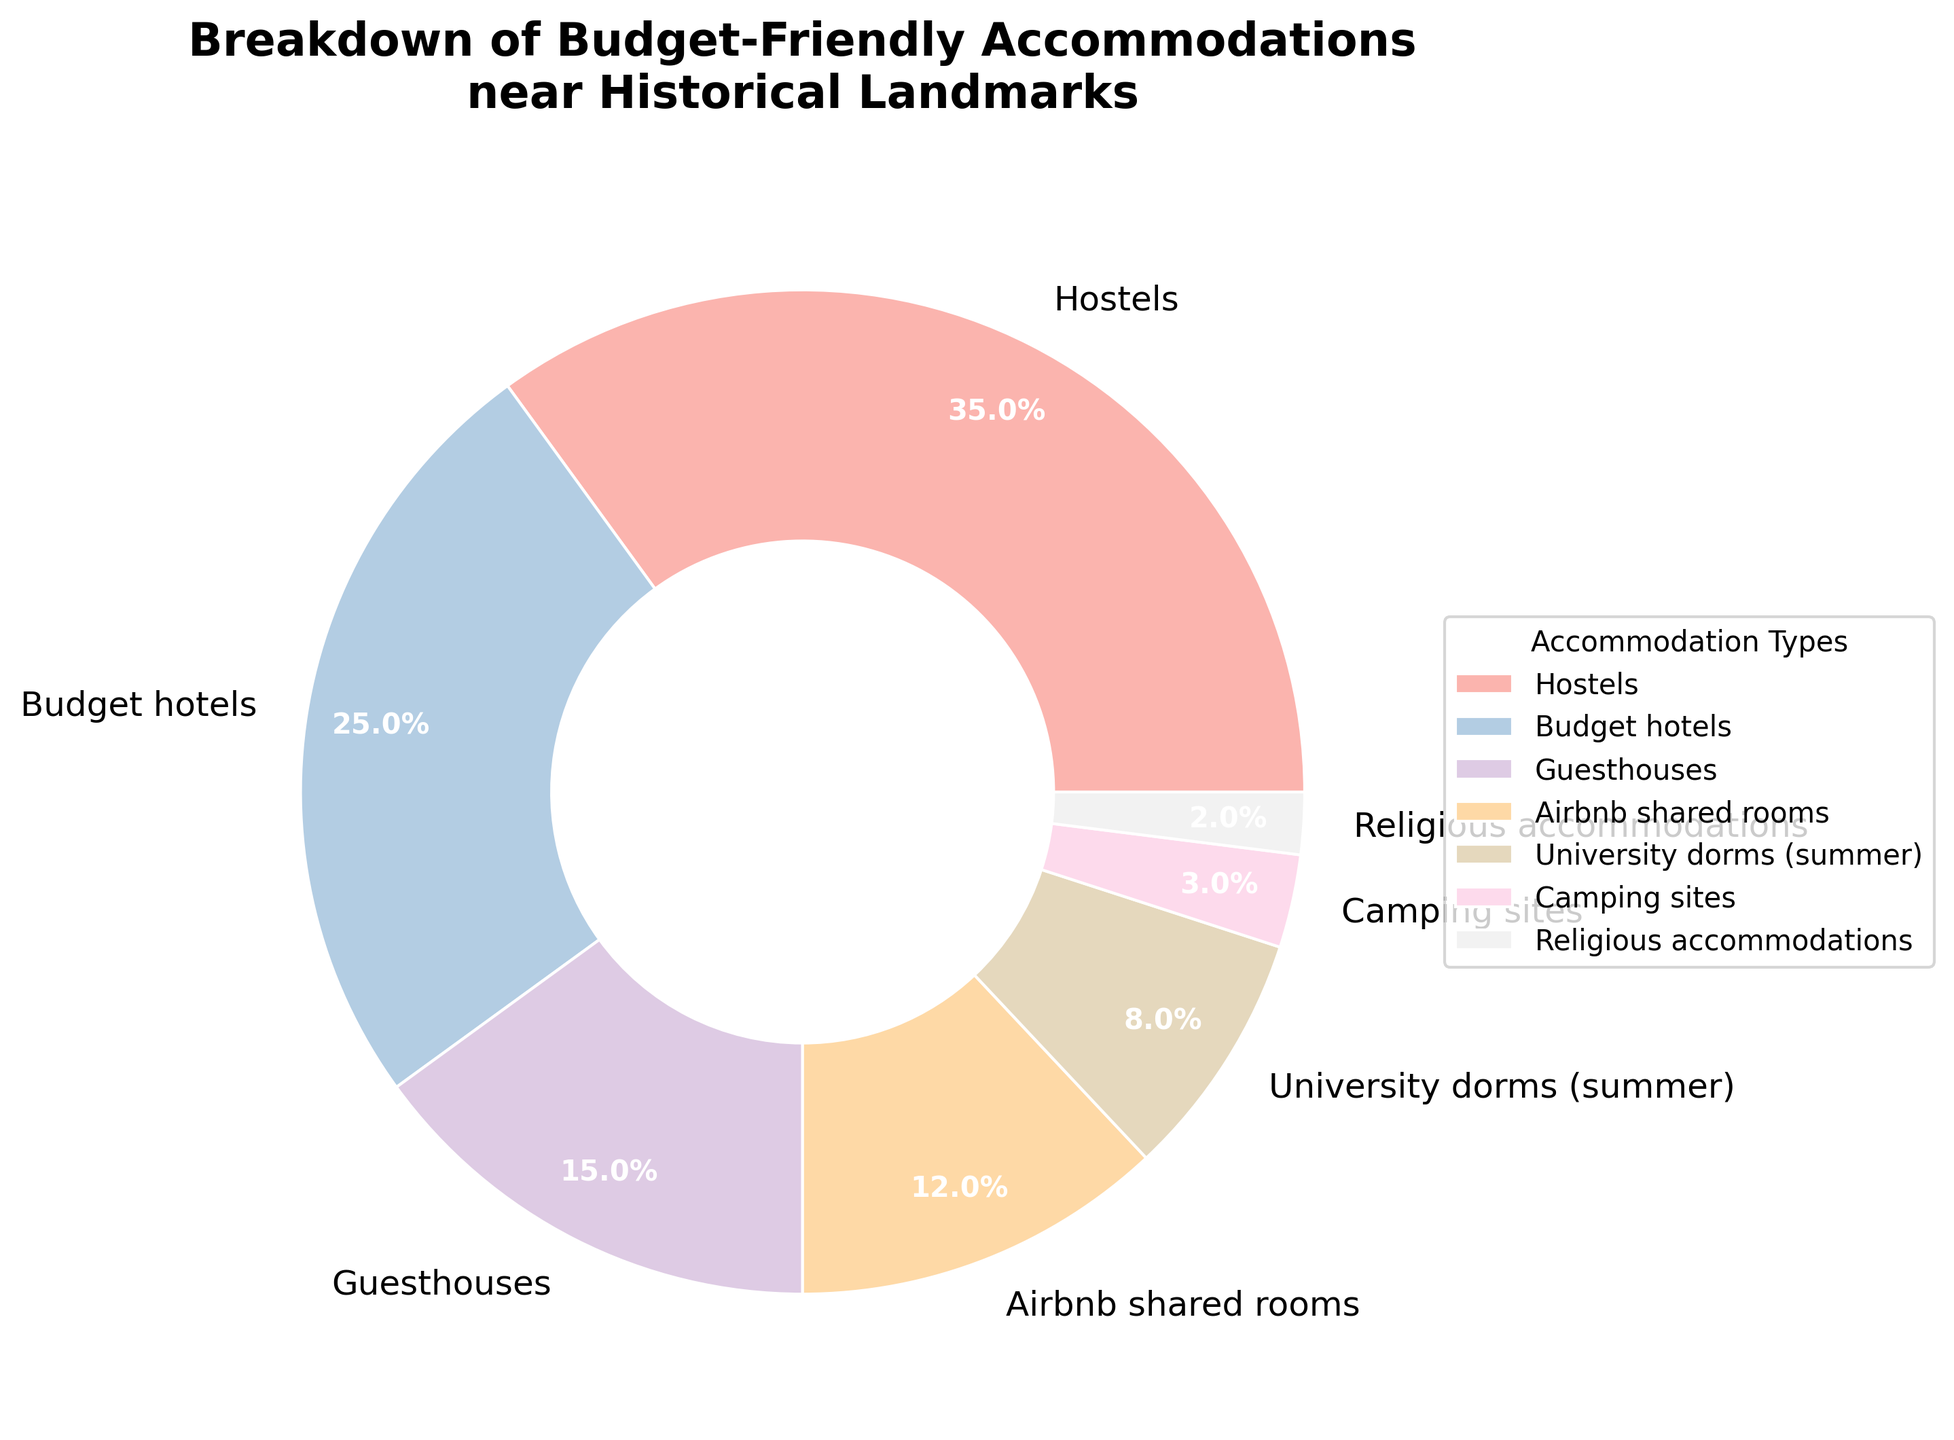What percentage of accommodations are either Hostels or Budget hotels? To find this, sum the percentages of Hostels and Budget hotels. Hostels account for 35% and Budget hotels account for 25%. Thus, 35% + 25% = 60%.
Answer: 60% Which accommodation type has the smallest percentage? Look at the percentages for all accommodation types. The smallest percentage is 2%, which corresponds to Religious accommodations.
Answer: Religious accommodations Are there more Guesthouses or Airbnb shared rooms? Compare the percentages of Guesthouses and Airbnb shared rooms. Guesthouses have 15%, while Airbnb shared rooms have 12%. Since 15% is greater than 12%, there are more Guesthouses.
Answer: Guesthouses What is the combined percentage of the three least common accommodation types? Identify the three least common types: Religious accommodations (2%), Camping sites (3%), and University dorms (8%). Sum these percentages: 2% + 3% + 8% = 13%.
Answer: 13% Which two accommodation types together make up more than 50% of the total? Look for the highest two percentages and sum them. Hostels account for 35% and Budget hotels account for 25%. Together, they make up 35% + 25% = 60%, which is more than 50%.
Answer: Hostels and Budget hotels Do Hostels and Guesthouses together make up a higher percentage than Budget hotels alone? Sum the percentages of Hostels and Guesthouses: 35% + 15% = 50%. Compare this to the percentage of Budget hotels (25%). 50% is greater than 25%.
Answer: Yes What is the difference in percentage between Budget hotels and University dorms (summer)? Subtract the percentage of University dorms from Budget hotels: 25% - 8% = 17%.
Answer: 17% Are University dorms (summer) more common than Camping sites and Religious accommodations combined? Sum the percentages of Camping sites (3%) and Religious accommodations (2%): 3% + 2% = 5%. Compare this to University dorms (8%). 8% is greater than 5%.
Answer: Yes Which accommodation type is represented with a lighter shade (higher value) in the color spectrum used? The color spectrum uses lighter shades for higher values. The highest value is 35% for Hostels.
Answer: Hostels 